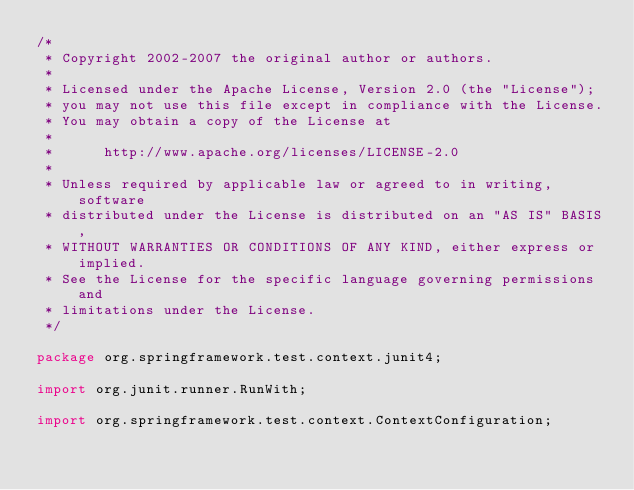Convert code to text. <code><loc_0><loc_0><loc_500><loc_500><_Java_>/*
 * Copyright 2002-2007 the original author or authors.
 *
 * Licensed under the Apache License, Version 2.0 (the "License");
 * you may not use this file except in compliance with the License.
 * You may obtain a copy of the License at
 *
 *      http://www.apache.org/licenses/LICENSE-2.0
 *
 * Unless required by applicable law or agreed to in writing, software
 * distributed under the License is distributed on an "AS IS" BASIS,
 * WITHOUT WARRANTIES OR CONDITIONS OF ANY KIND, either express or implied.
 * See the License for the specific language governing permissions and
 * limitations under the License.
 */

package org.springframework.test.context.junit4;

import org.junit.runner.RunWith;

import org.springframework.test.context.ContextConfiguration;
</code> 